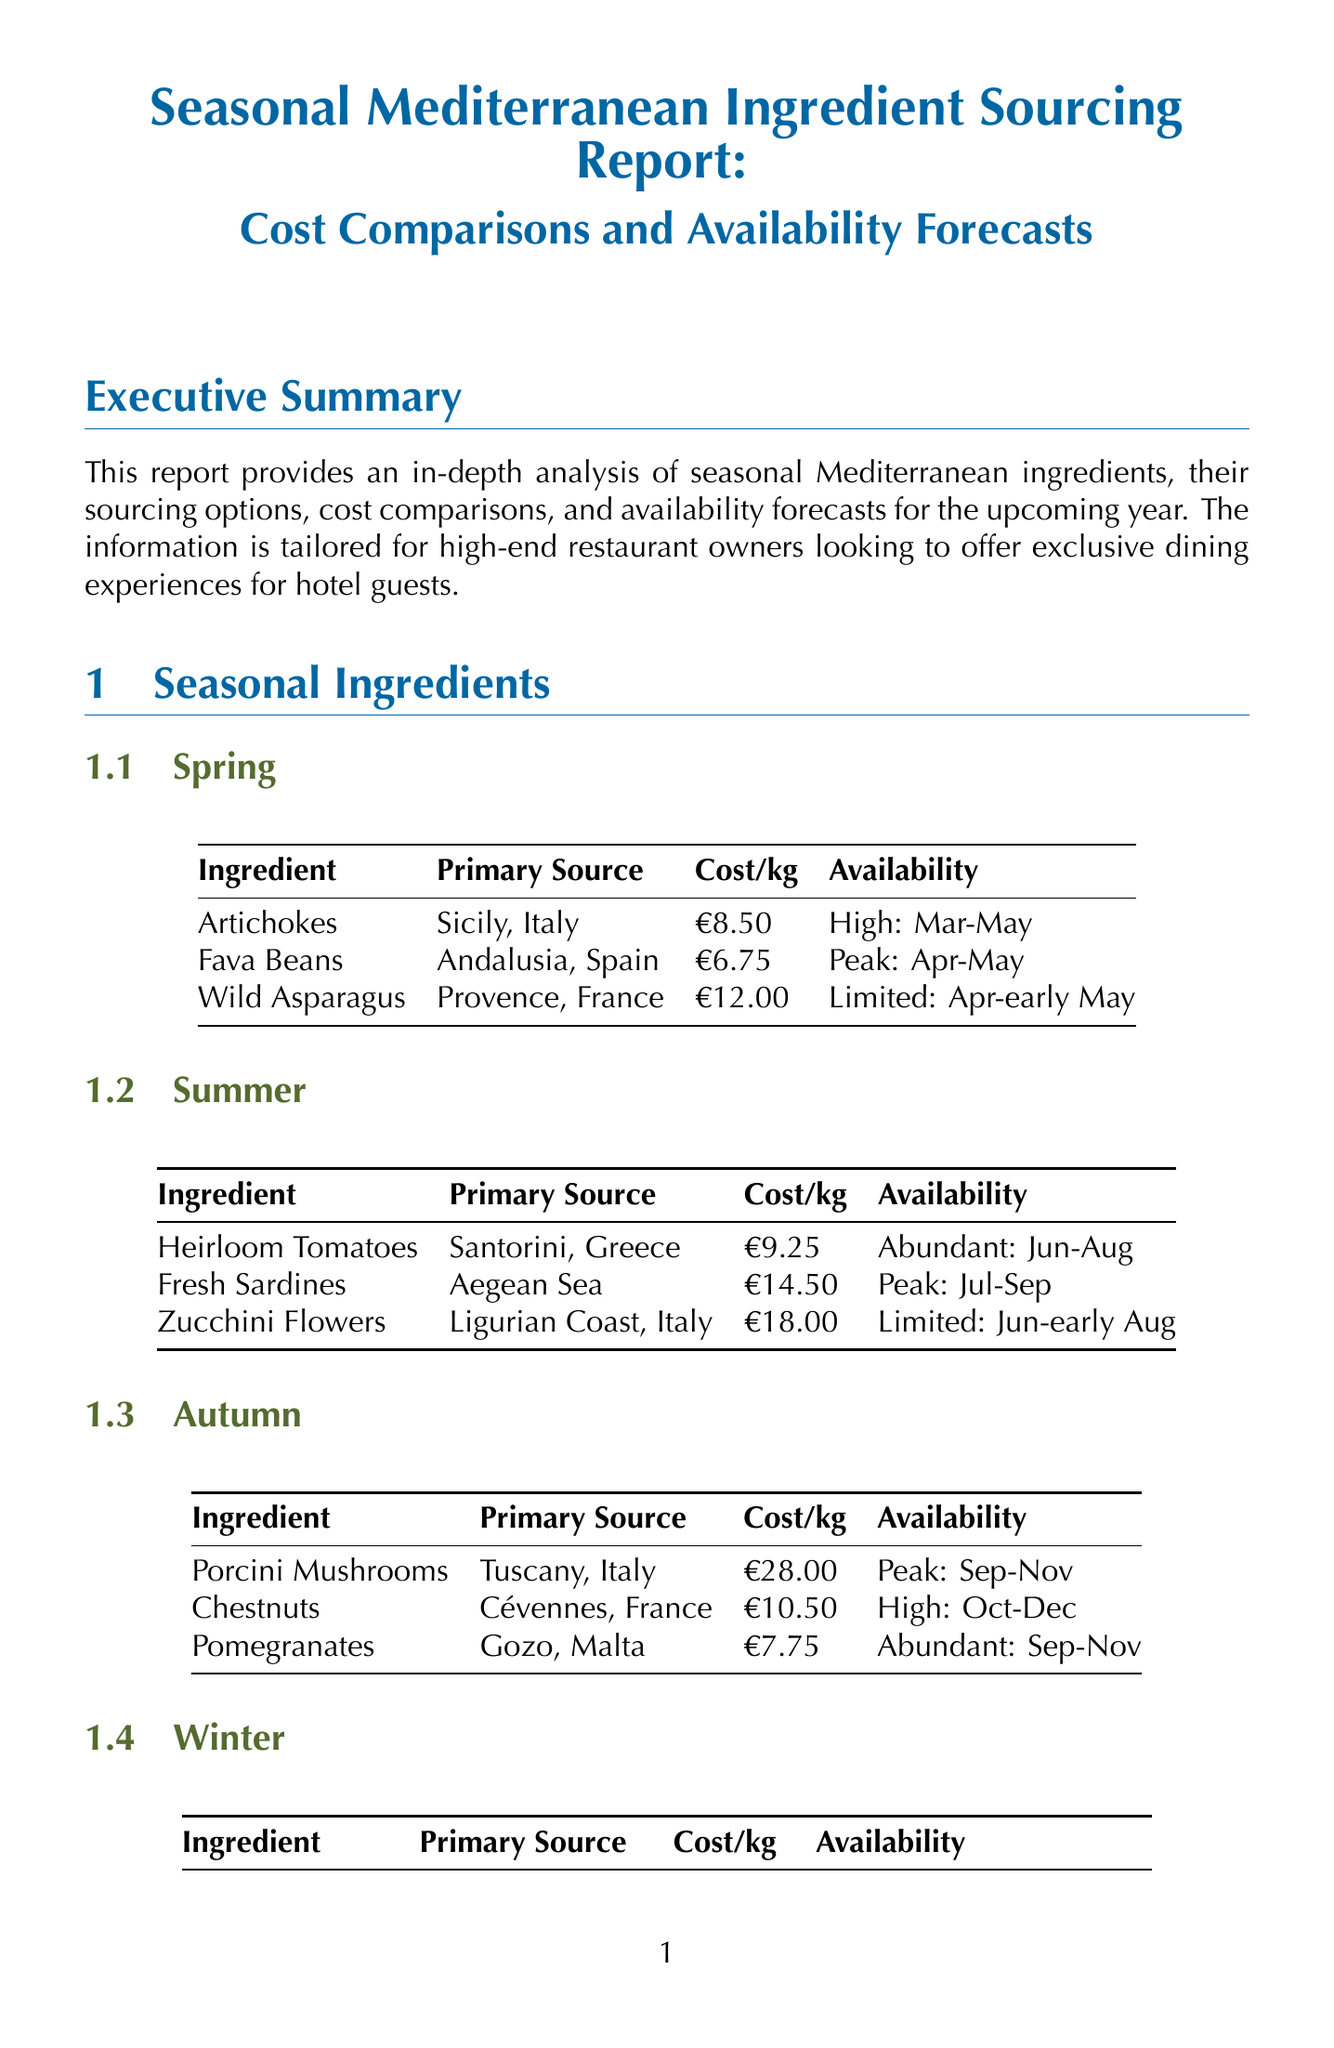What is the primary source of Heirloom Tomatoes? The primary source of Heirloom Tomatoes is Santorini, Greece.
Answer: Santorini, Greece What is the cost per kilogram of Black Truffles? The cost per kilogram of Black Truffles is detailed in the document.
Answer: €850.00 Which sourcing strategy supports local communities? The sourcing strategy that supports local communities is described in the document.
Answer: Direct Farm Partnerships During which months are Fava Beans in peak season? Fava Beans' peak season is mentioned in relation to specific months.
Answer: April and May What is a recommended cost-saving recommendation in the report? One of the cost-saving recommendations is provided in a bullet point format in the document.
Answer: Implement a dynamic menu that adapts to seasonal ingredient availability How many exclusive dining experience ideas are mentioned in the report? The total number of exclusive dining experience ideas can be counted in the list provided in the document.
Answer: Three What is the availability forecast for Seville Oranges? The availability forecast for Seville Oranges is explained in the related section of the document.
Answer: Peak: December to February What is the trend regarding lesser-known Mediterranean cuisines? The document discusses market trends, including growing interest in certain cuisines.
Answer: Growing interest in lesser-known Mediterranean cuisines (e.g., Corsican, Cypriot) 